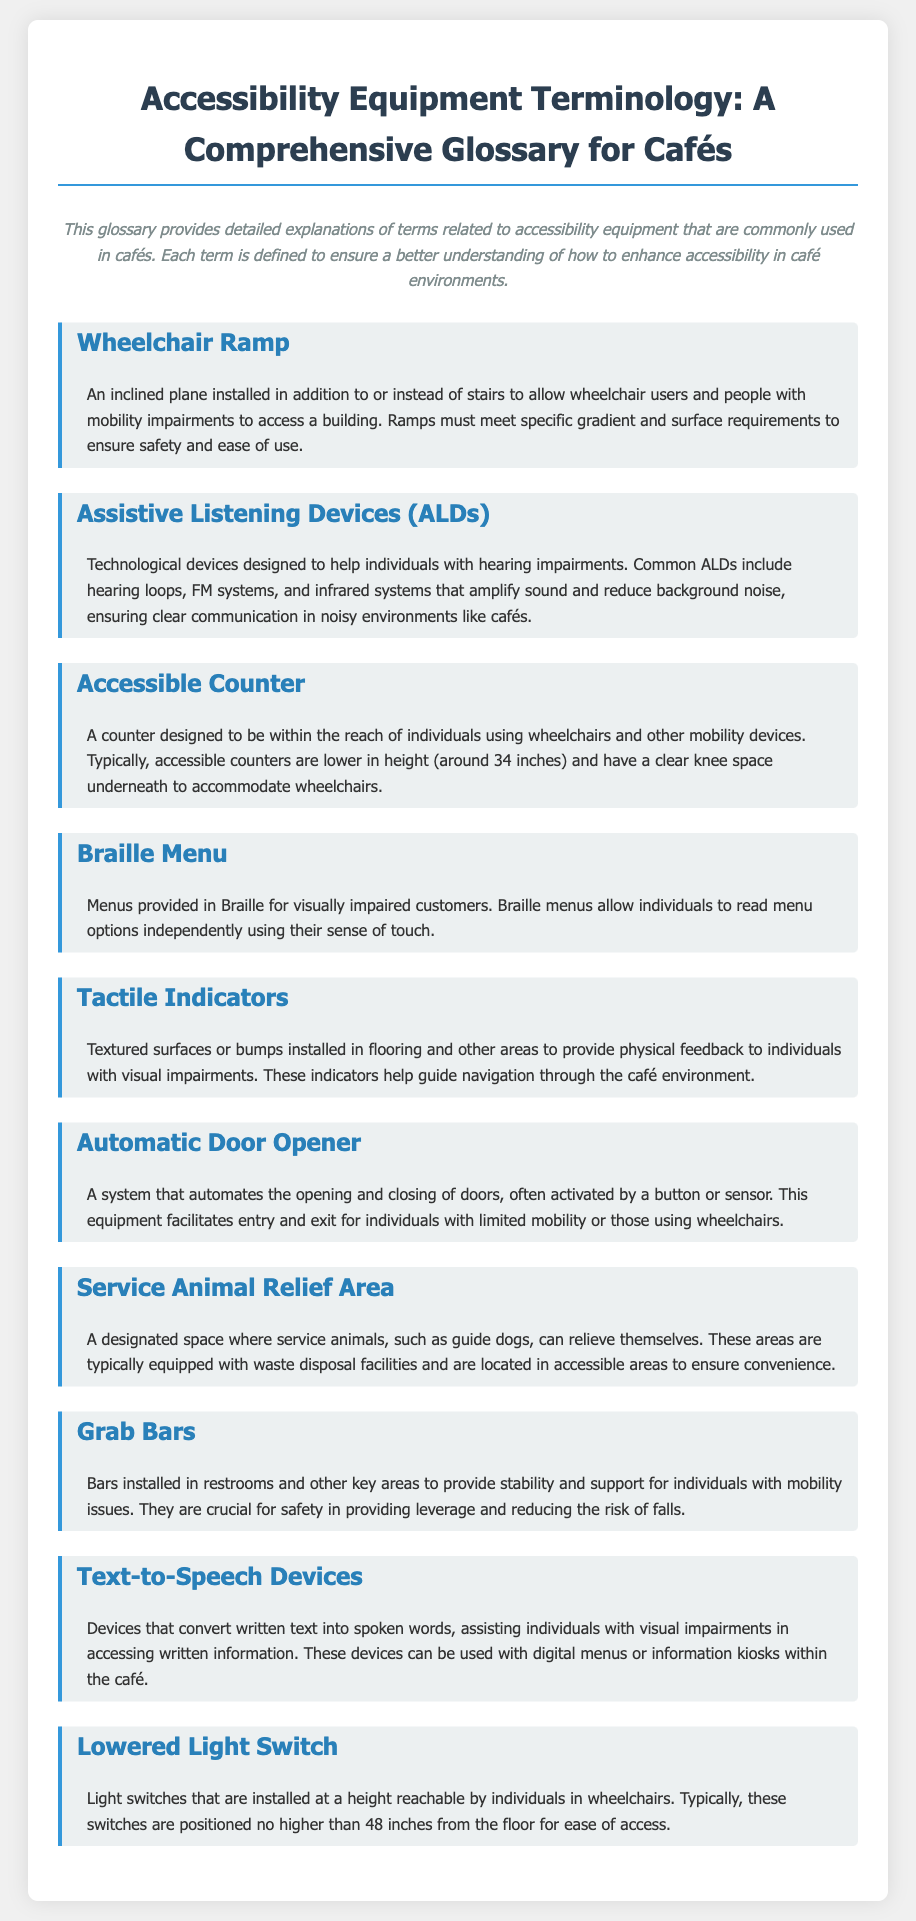What is an inclined plane for wheelchair users? An inclined plane installed in addition to or instead of stairs to allow wheelchair users and people with mobility impairments to access a building.
Answer: Wheelchair Ramp What is the typical height of an accessible counter? Accessible counters are lower in height to accommodate wheelchairs, typically around 34 inches.
Answer: 34 inches What do assistive listening devices amplify? They amplify sound and reduce background noise.
Answer: Sound What is the purpose of tactile indicators? Textured surfaces or bumps installed to provide physical feedback for navigation through the café.
Answer: Navigation What is a designated space for service animals called? A designated space where service animals can relieve themselves.
Answer: Service Animal Relief Area What is the maximum height for a lowered light switch? Typically, these switches are positioned no higher than 48 inches from the floor.
Answer: 48 inches What type of device helps individuals with visual impairments read menus? Devices that convert written text into spoken words.
Answer: Text-to-Speech Devices What do grab bars provide for individuals with mobility issues? Bars installed in key areas to provide stability and support.
Answer: Stability What technology amplifies sound in noisy environments? Technological devices designed to help individuals with hearing impairments.
Answer: Assistive Listening Devices (ALDs) 